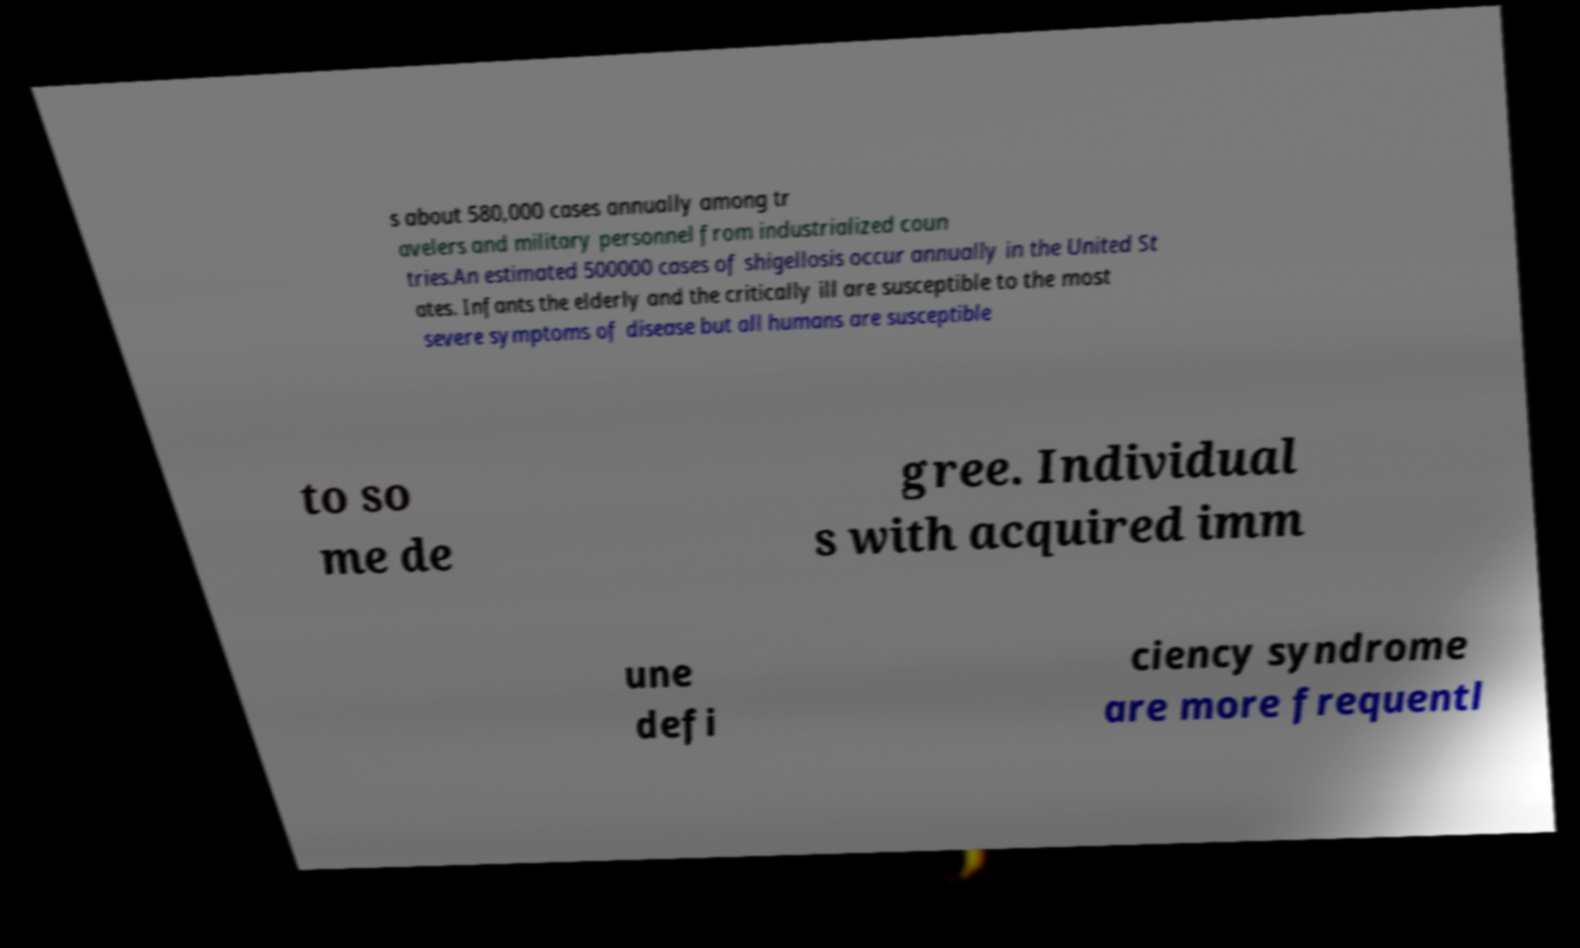Could you assist in decoding the text presented in this image and type it out clearly? s about 580,000 cases annually among tr avelers and military personnel from industrialized coun tries.An estimated 500000 cases of shigellosis occur annually in the United St ates. Infants the elderly and the critically ill are susceptible to the most severe symptoms of disease but all humans are susceptible to so me de gree. Individual s with acquired imm une defi ciency syndrome are more frequentl 